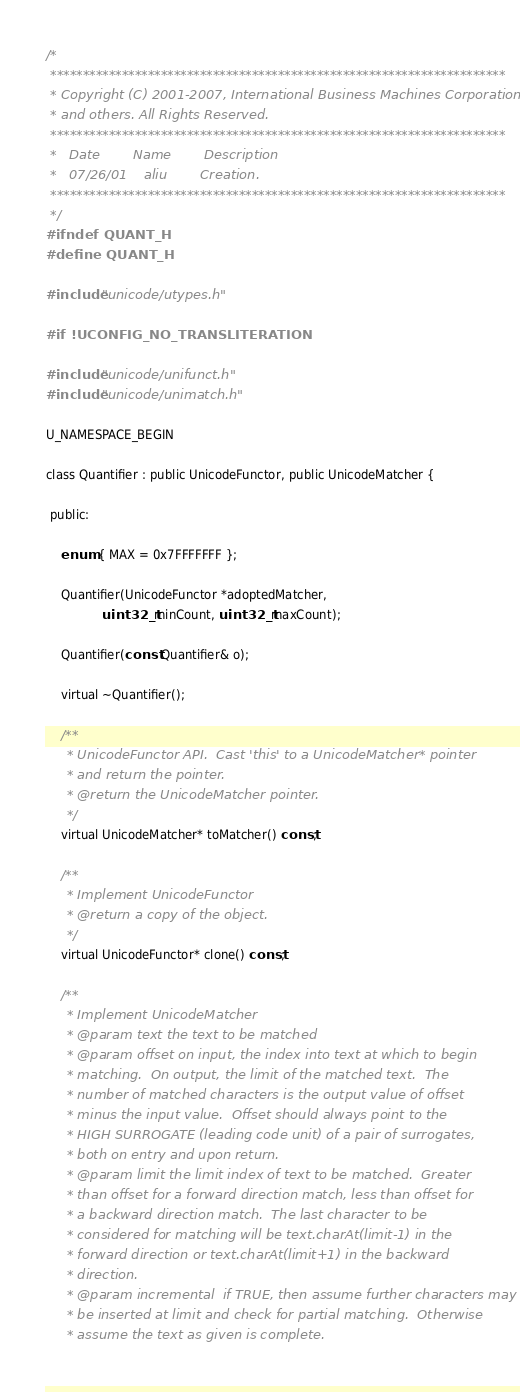<code> <loc_0><loc_0><loc_500><loc_500><_C_>/*
 **********************************************************************
 * Copyright (C) 2001-2007, International Business Machines Corporation
 * and others. All Rights Reserved.
 **********************************************************************
 *   Date        Name        Description
 *   07/26/01    aliu        Creation.
 **********************************************************************
 */
#ifndef QUANT_H
#define QUANT_H

#include "unicode/utypes.h"

#if !UCONFIG_NO_TRANSLITERATION

#include "unicode/unifunct.h"
#include "unicode/unimatch.h"

U_NAMESPACE_BEGIN

class Quantifier : public UnicodeFunctor, public UnicodeMatcher {

 public:

    enum { MAX = 0x7FFFFFFF };

    Quantifier(UnicodeFunctor *adoptedMatcher,
               uint32_t minCount, uint32_t maxCount);

    Quantifier(const Quantifier& o);

    virtual ~Quantifier();

    /**
     * UnicodeFunctor API.  Cast 'this' to a UnicodeMatcher* pointer
     * and return the pointer.
     * @return the UnicodeMatcher pointer.
     */
    virtual UnicodeMatcher* toMatcher() const;

    /**
     * Implement UnicodeFunctor
     * @return a copy of the object.
     */
    virtual UnicodeFunctor* clone() const;

    /**
     * Implement UnicodeMatcher
     * @param text the text to be matched
     * @param offset on input, the index into text at which to begin
     * matching.  On output, the limit of the matched text.  The
     * number of matched characters is the output value of offset
     * minus the input value.  Offset should always point to the
     * HIGH SURROGATE (leading code unit) of a pair of surrogates,
     * both on entry and upon return.
     * @param limit the limit index of text to be matched.  Greater
     * than offset for a forward direction match, less than offset for
     * a backward direction match.  The last character to be
     * considered for matching will be text.charAt(limit-1) in the
     * forward direction or text.charAt(limit+1) in the backward
     * direction.
     * @param incremental  if TRUE, then assume further characters may
     * be inserted at limit and check for partial matching.  Otherwise
     * assume the text as given is complete.</code> 